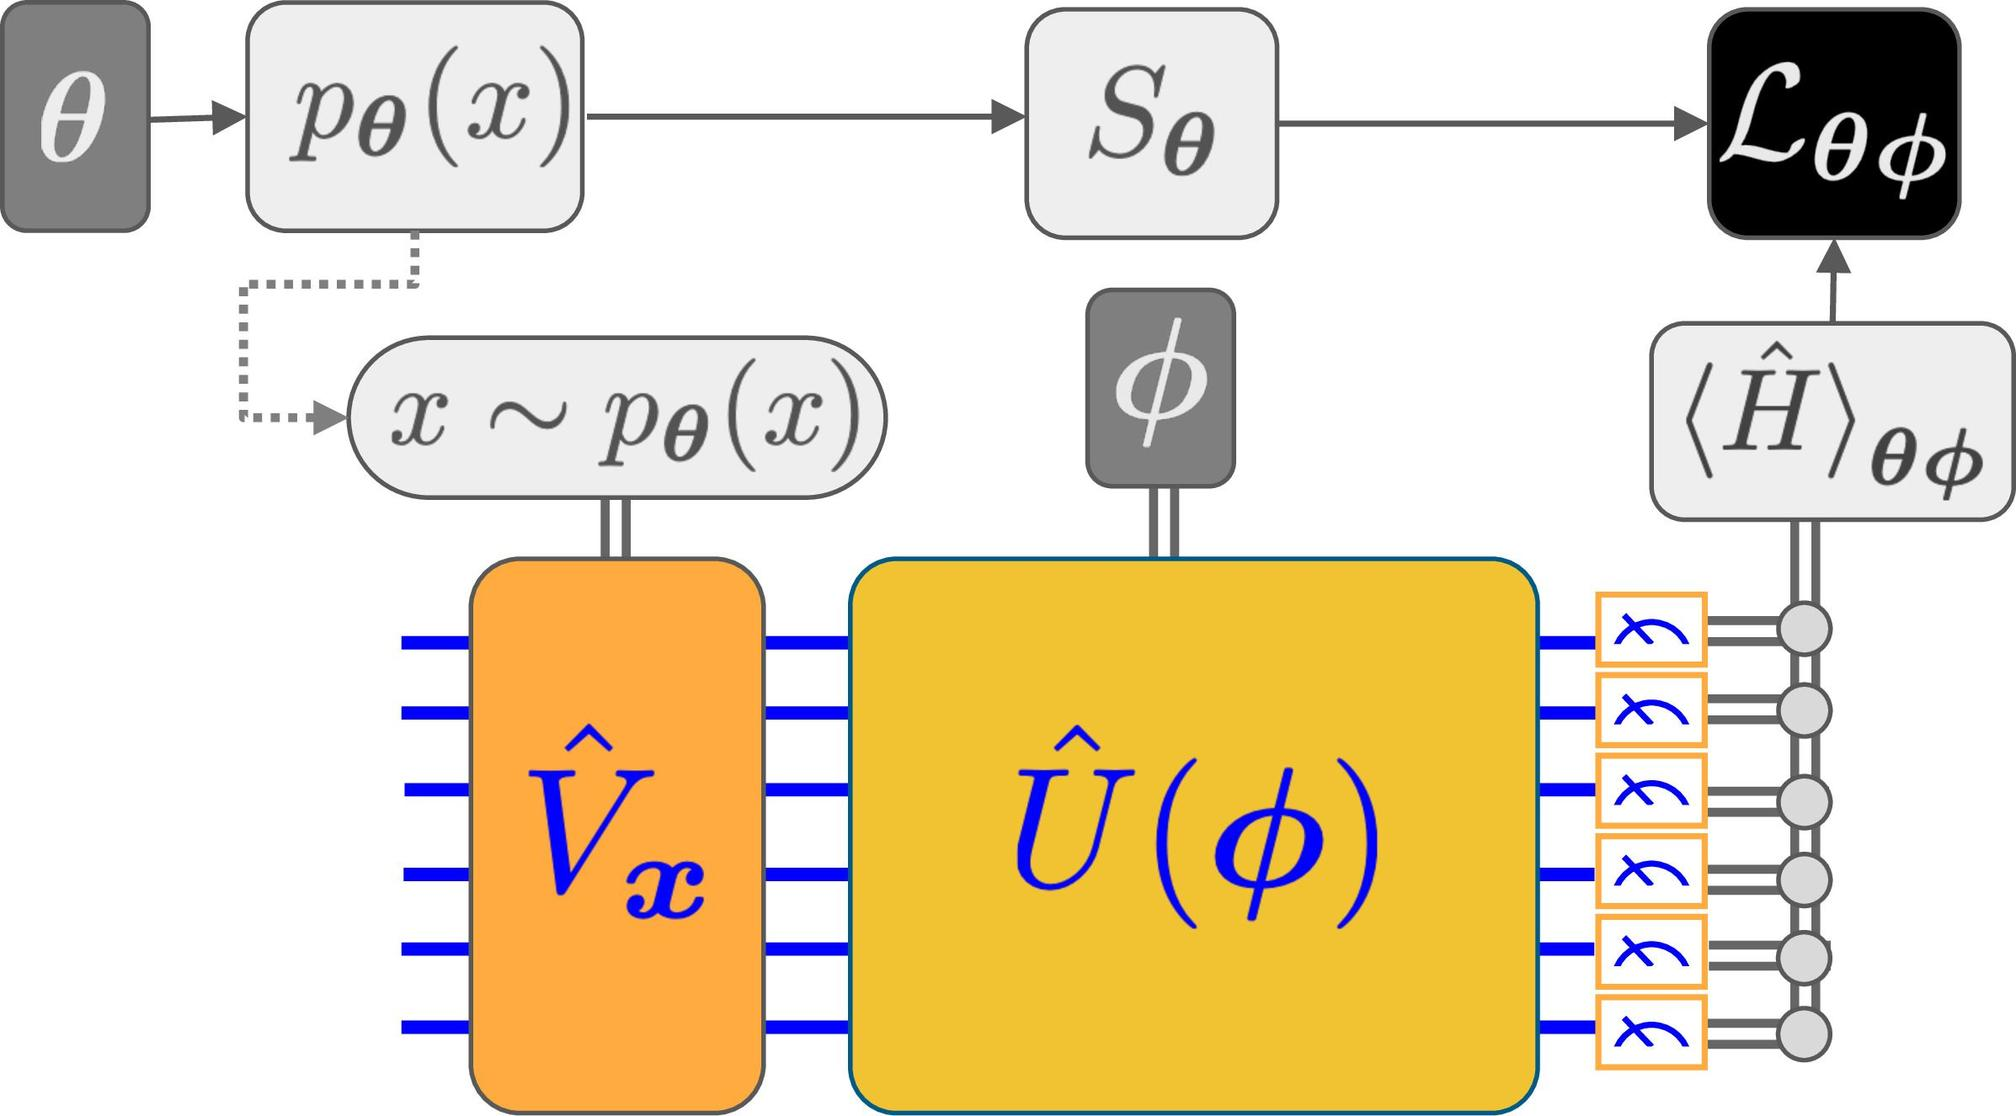What can be inferred about the role of \(S_{\theta}\) in the diagram? In the provided diagram, \(S_{\theta}\) appears to be directly linked to \(p_{\theta}(x)\), suggesting that its primary function is to select or manipulate states based on the parameter \(\theta\). This selection process is crucial as it influences the behavior and outcome observed in the subsequent modules of the diagram, particularly impacting how the system processes these selected states further. By controlling which states are forwarded through the system, \(S_{\theta}\) plays an integral role in determining the overall system behavior in response to variations in \(\theta\). Therefore, the most appropriate answer would be A, indicating that \(S_{\theta}\) selects a specific state based on the parameter \(\theta\). 